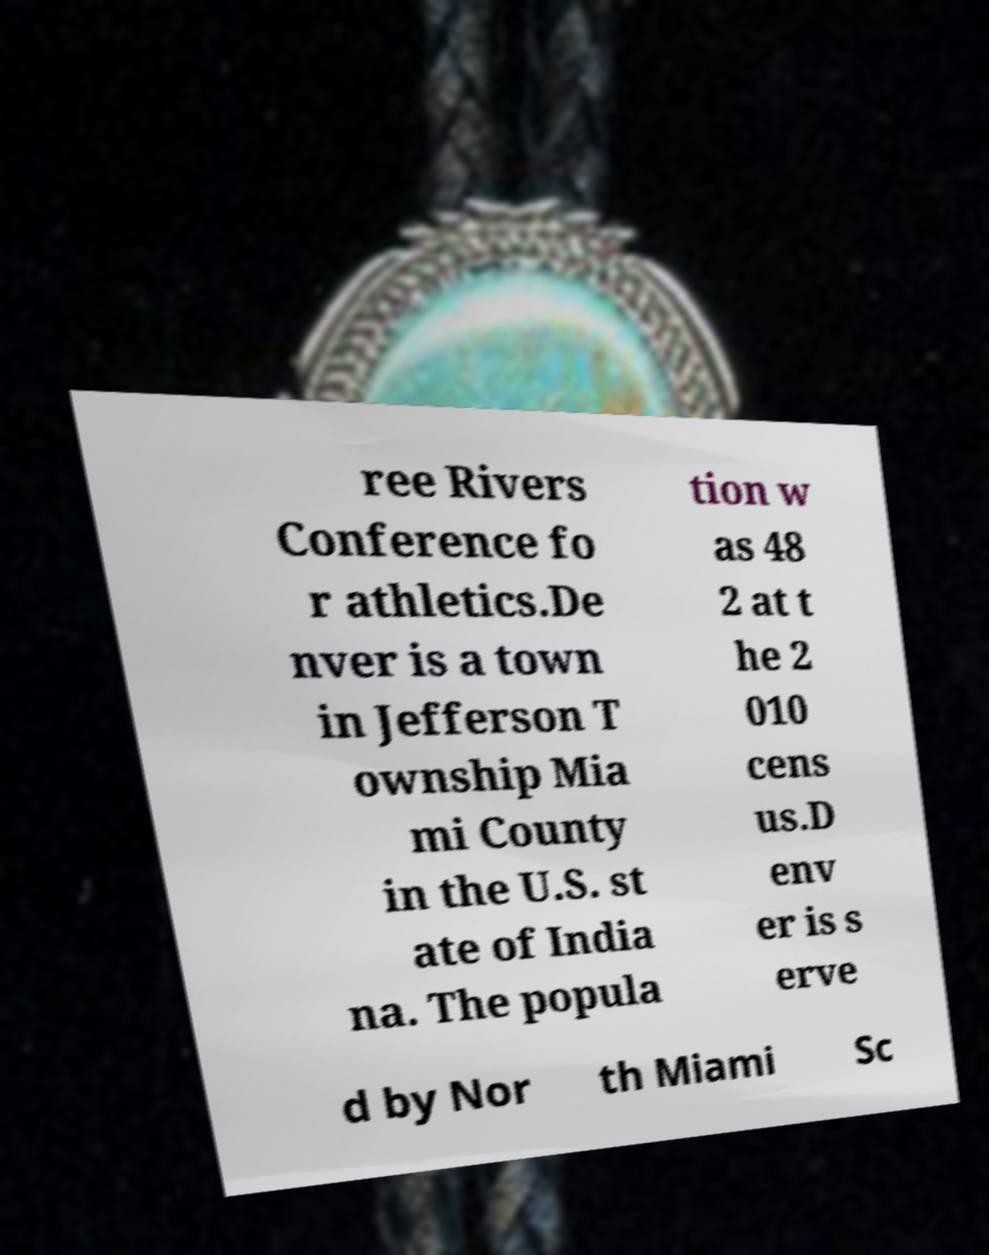I need the written content from this picture converted into text. Can you do that? ree Rivers Conference fo r athletics.De nver is a town in Jefferson T ownship Mia mi County in the U.S. st ate of India na. The popula tion w as 48 2 at t he 2 010 cens us.D env er is s erve d by Nor th Miami Sc 